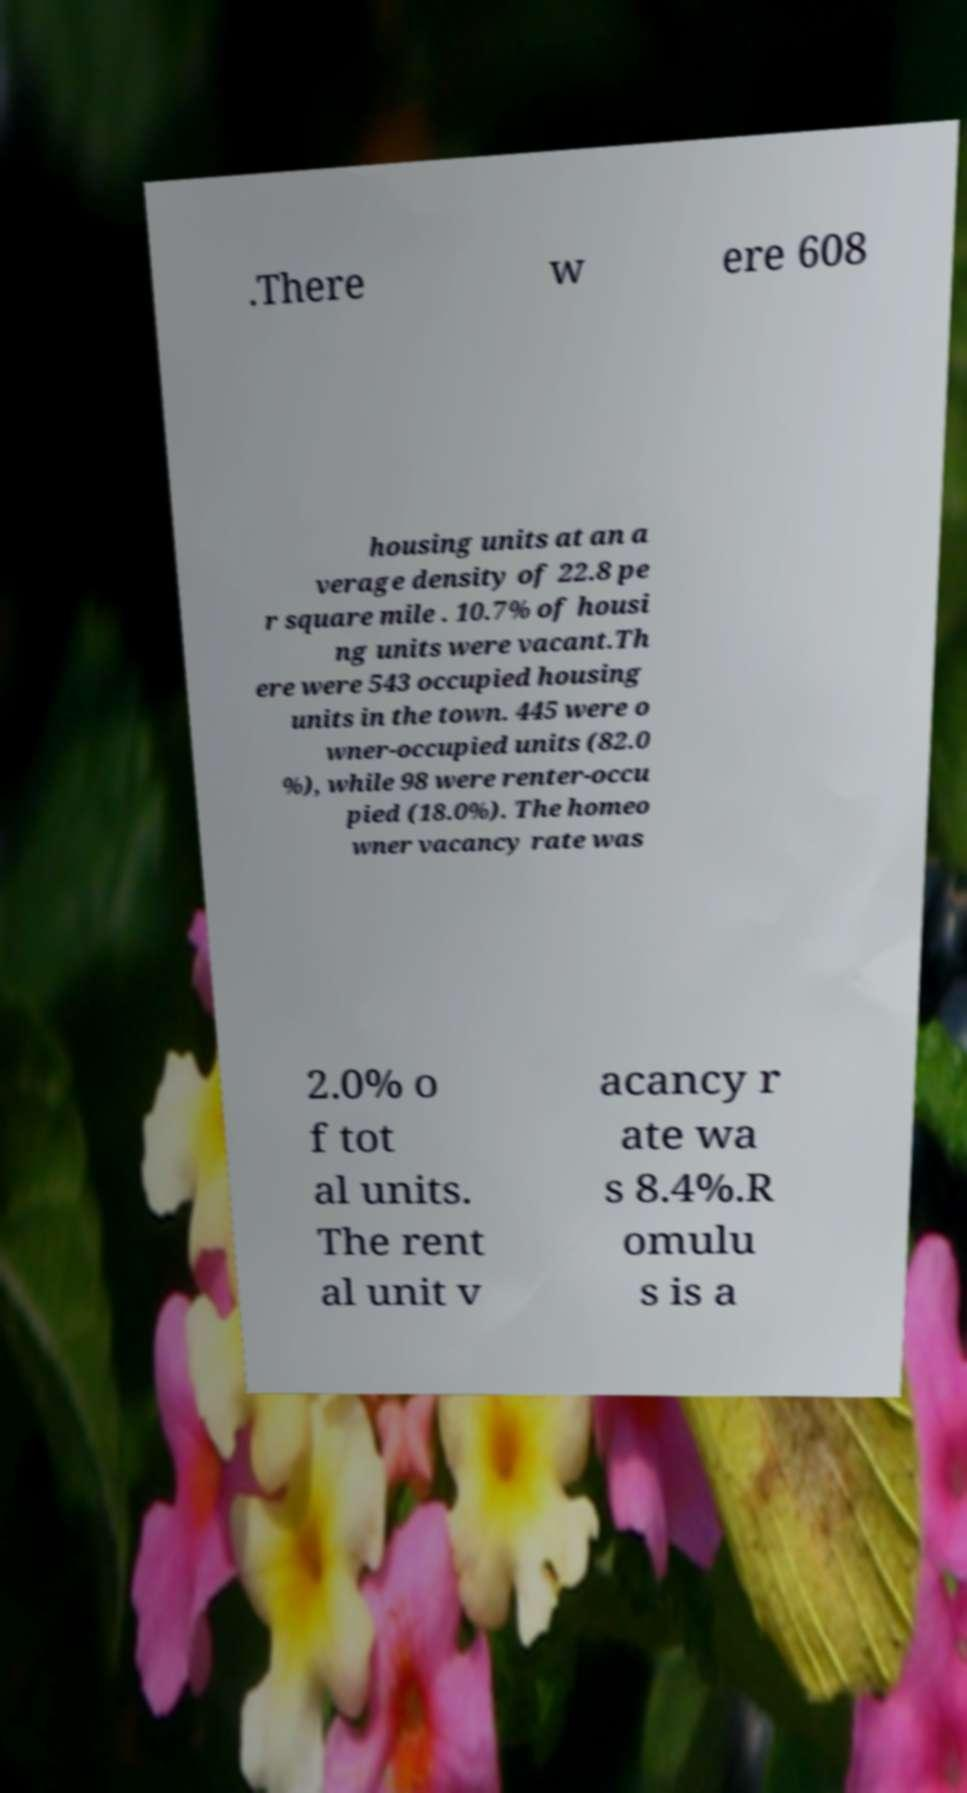Can you read and provide the text displayed in the image?This photo seems to have some interesting text. Can you extract and type it out for me? .There w ere 608 housing units at an a verage density of 22.8 pe r square mile . 10.7% of housi ng units were vacant.Th ere were 543 occupied housing units in the town. 445 were o wner-occupied units (82.0 %), while 98 were renter-occu pied (18.0%). The homeo wner vacancy rate was 2.0% o f tot al units. The rent al unit v acancy r ate wa s 8.4%.R omulu s is a 